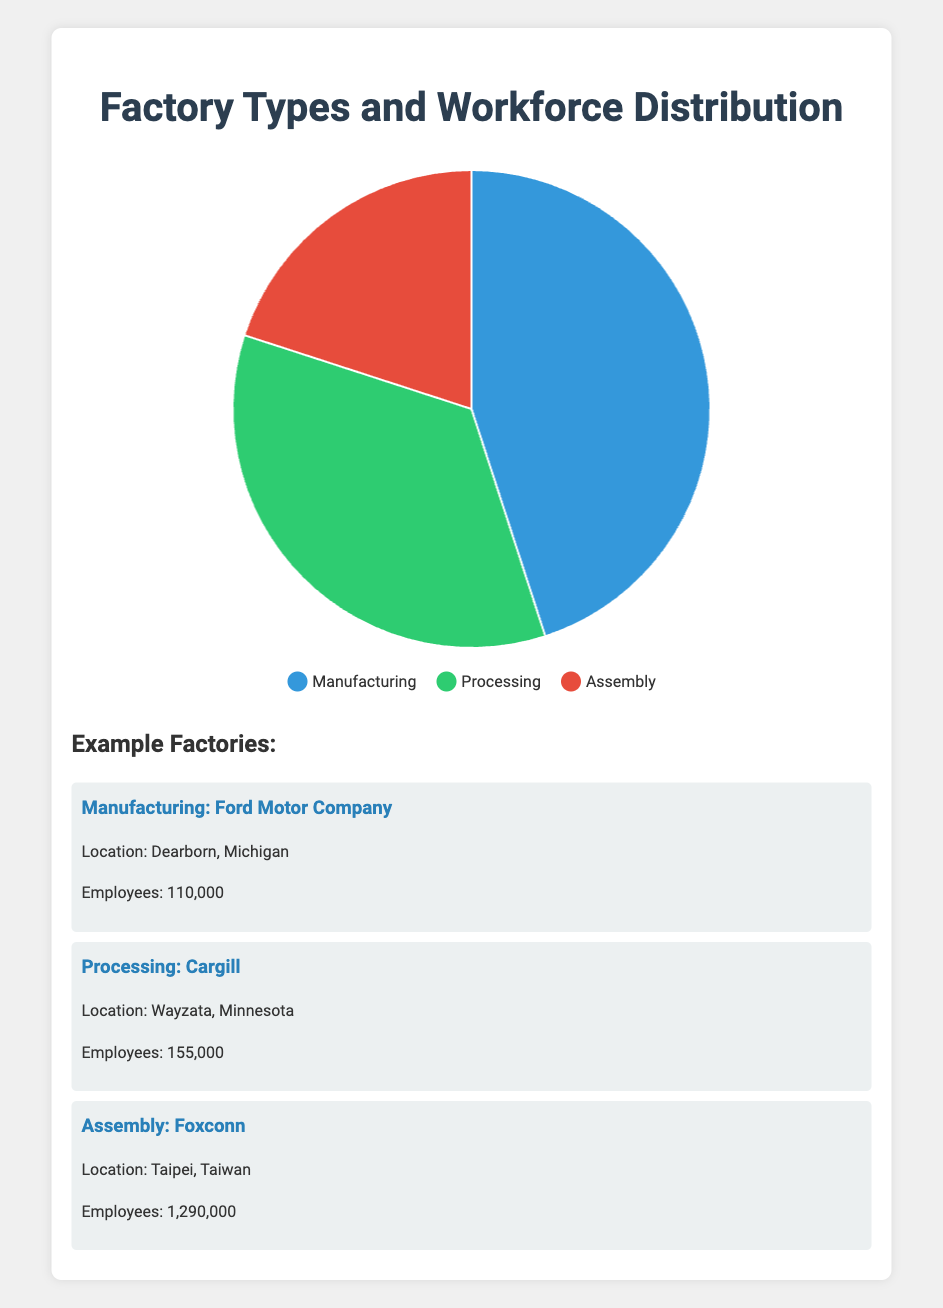What is the percentage of the workforce in Manufacturing? The pie chart reveals that Manufacturing occupies 45% of the workforce.
Answer: 45% What proportion of the workforce is involved in Processing compared to Assembly? Processing accounts for 35% while Assembly accounts for 20%. 35% is greater than 20%.
Answer: Processing > Assembly Which factory type has the largest workforce percentage? By looking at the pie chart, Manufacturing has the largest workforce percentage at 45%.
Answer: Manufacturing What is the combined percentage of the workforce in Manufacturing and Assembly? The combined percentage is calculated by adding the Manufacturing (45%) and Assembly (20%) percentages. Therefore, 45% + 20% = 65%.
Answer: 65% Among the provided examples, which Assembly factory has more employees? From the example factories, Foxconn has 1,290,000 employees, and Pegatron has 180,000 employees. Foxconn has more employees.
Answer: Foxconn How much larger is the workforce percentage in Manufacturing compared to Processing? The percentage of Manufacturing is 45%, while Processing is 35%. The difference is 45% - 35% = 10%.
Answer: 10% Which type of factory, Processing or Assembly, is more visualized with the color green? The pie chart uses green to represent Processing.
Answer: Processing What percentage of the workforce does not belong to Manufacturing? The percentage for non-Manufacturing factories is 100% - 45% = 55%.
Answer: 55% If another pie chart had the same proportions but represented 1000 workers, how many workers would belong to the Processing factories? Processing constitutes 35% of the workforce. If the total is 1000 workers, then 35% of 1000 is calculated as 1000 * 0.35 = 350.
Answer: 350 Is the percentage of the workforce in Manufacturing more than double that in Assembly? Manufacturing has 45%, and Assembly has 20%. Double of Assembly is 20% * 2 = 40%. Since 45% > 40%, Manufacturing is more than double.
Answer: Yes 